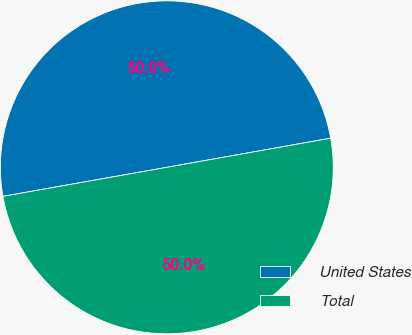Convert chart. <chart><loc_0><loc_0><loc_500><loc_500><pie_chart><fcel>United States<fcel>Total<nl><fcel>49.99%<fcel>50.01%<nl></chart> 